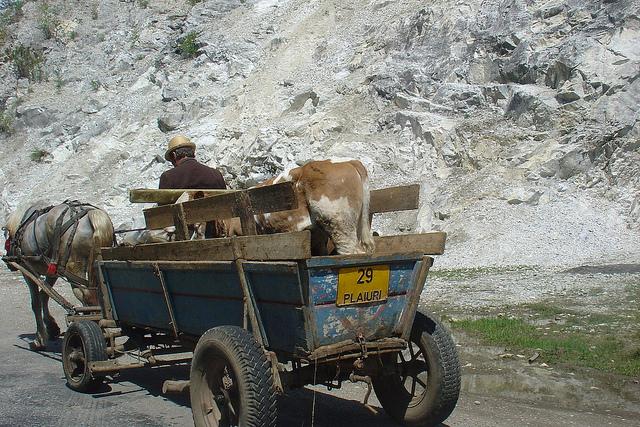Is the cart moving through flatlands?
Quick response, please. No. How can the man get the cow out of the cart without harming it?
Write a very short answer. Lowering back door. How many oxen are in the photo?
Give a very brief answer. 1. 